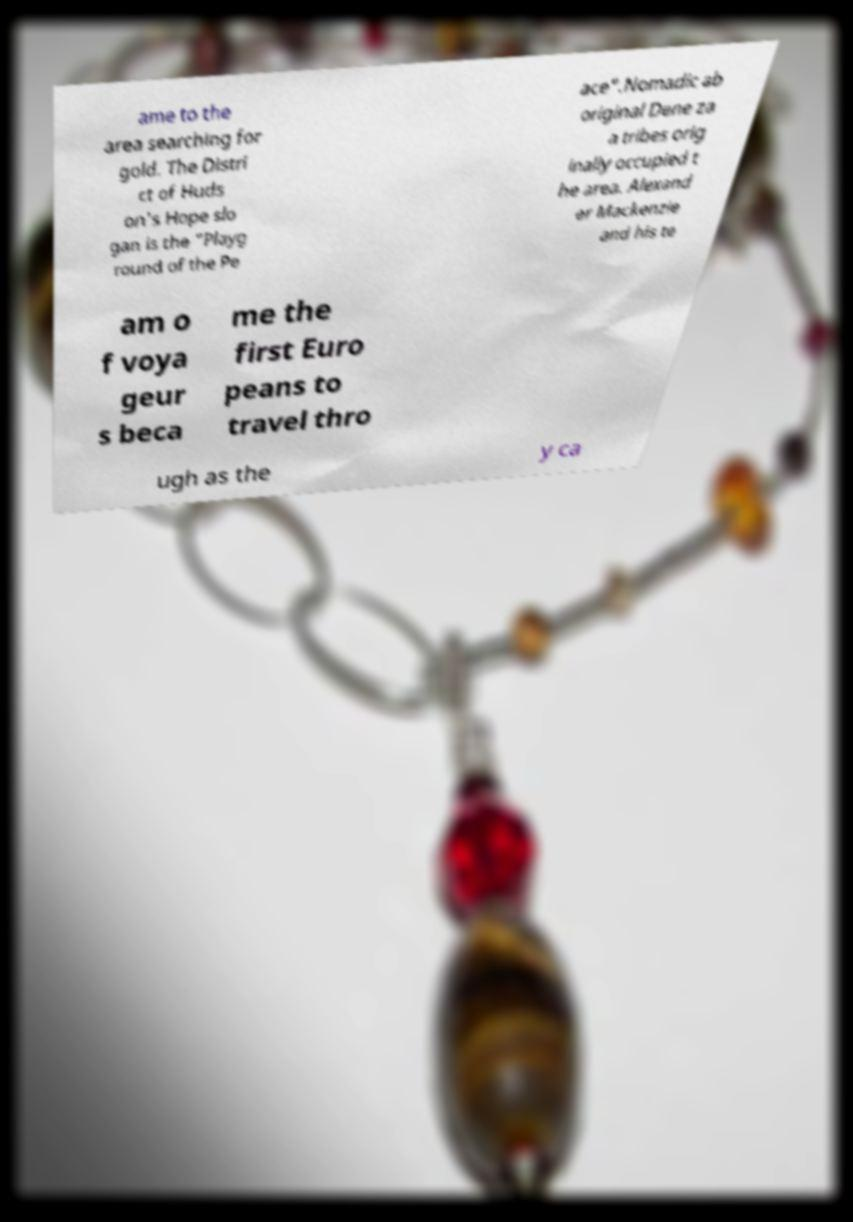Please read and relay the text visible in this image. What does it say? ame to the area searching for gold. The Distri ct of Huds on's Hope slo gan is the "Playg round of the Pe ace".Nomadic ab original Dene za a tribes orig inally occupied t he area. Alexand er Mackenzie and his te am o f voya geur s beca me the first Euro peans to travel thro ugh as the y ca 